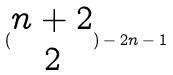Convert formula to latex. <formula><loc_0><loc_0><loc_500><loc_500>( \begin{matrix} n + 2 \\ 2 \end{matrix} ) - 2 n - 1</formula> 